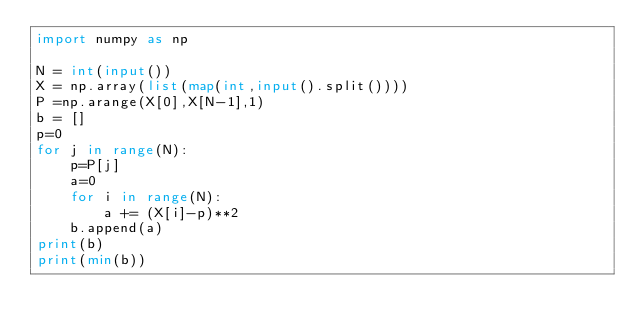<code> <loc_0><loc_0><loc_500><loc_500><_Python_>import numpy as np

N = int(input())
X = np.array(list(map(int,input().split())))
P =np.arange(X[0],X[N-1],1)
b = []
p=0
for j in range(N):
	p=P[j]
	a=0
	for i in range(N):
		a += (X[i]-p)**2
	b.append(a)
print(b)
print(min(b))
</code> 